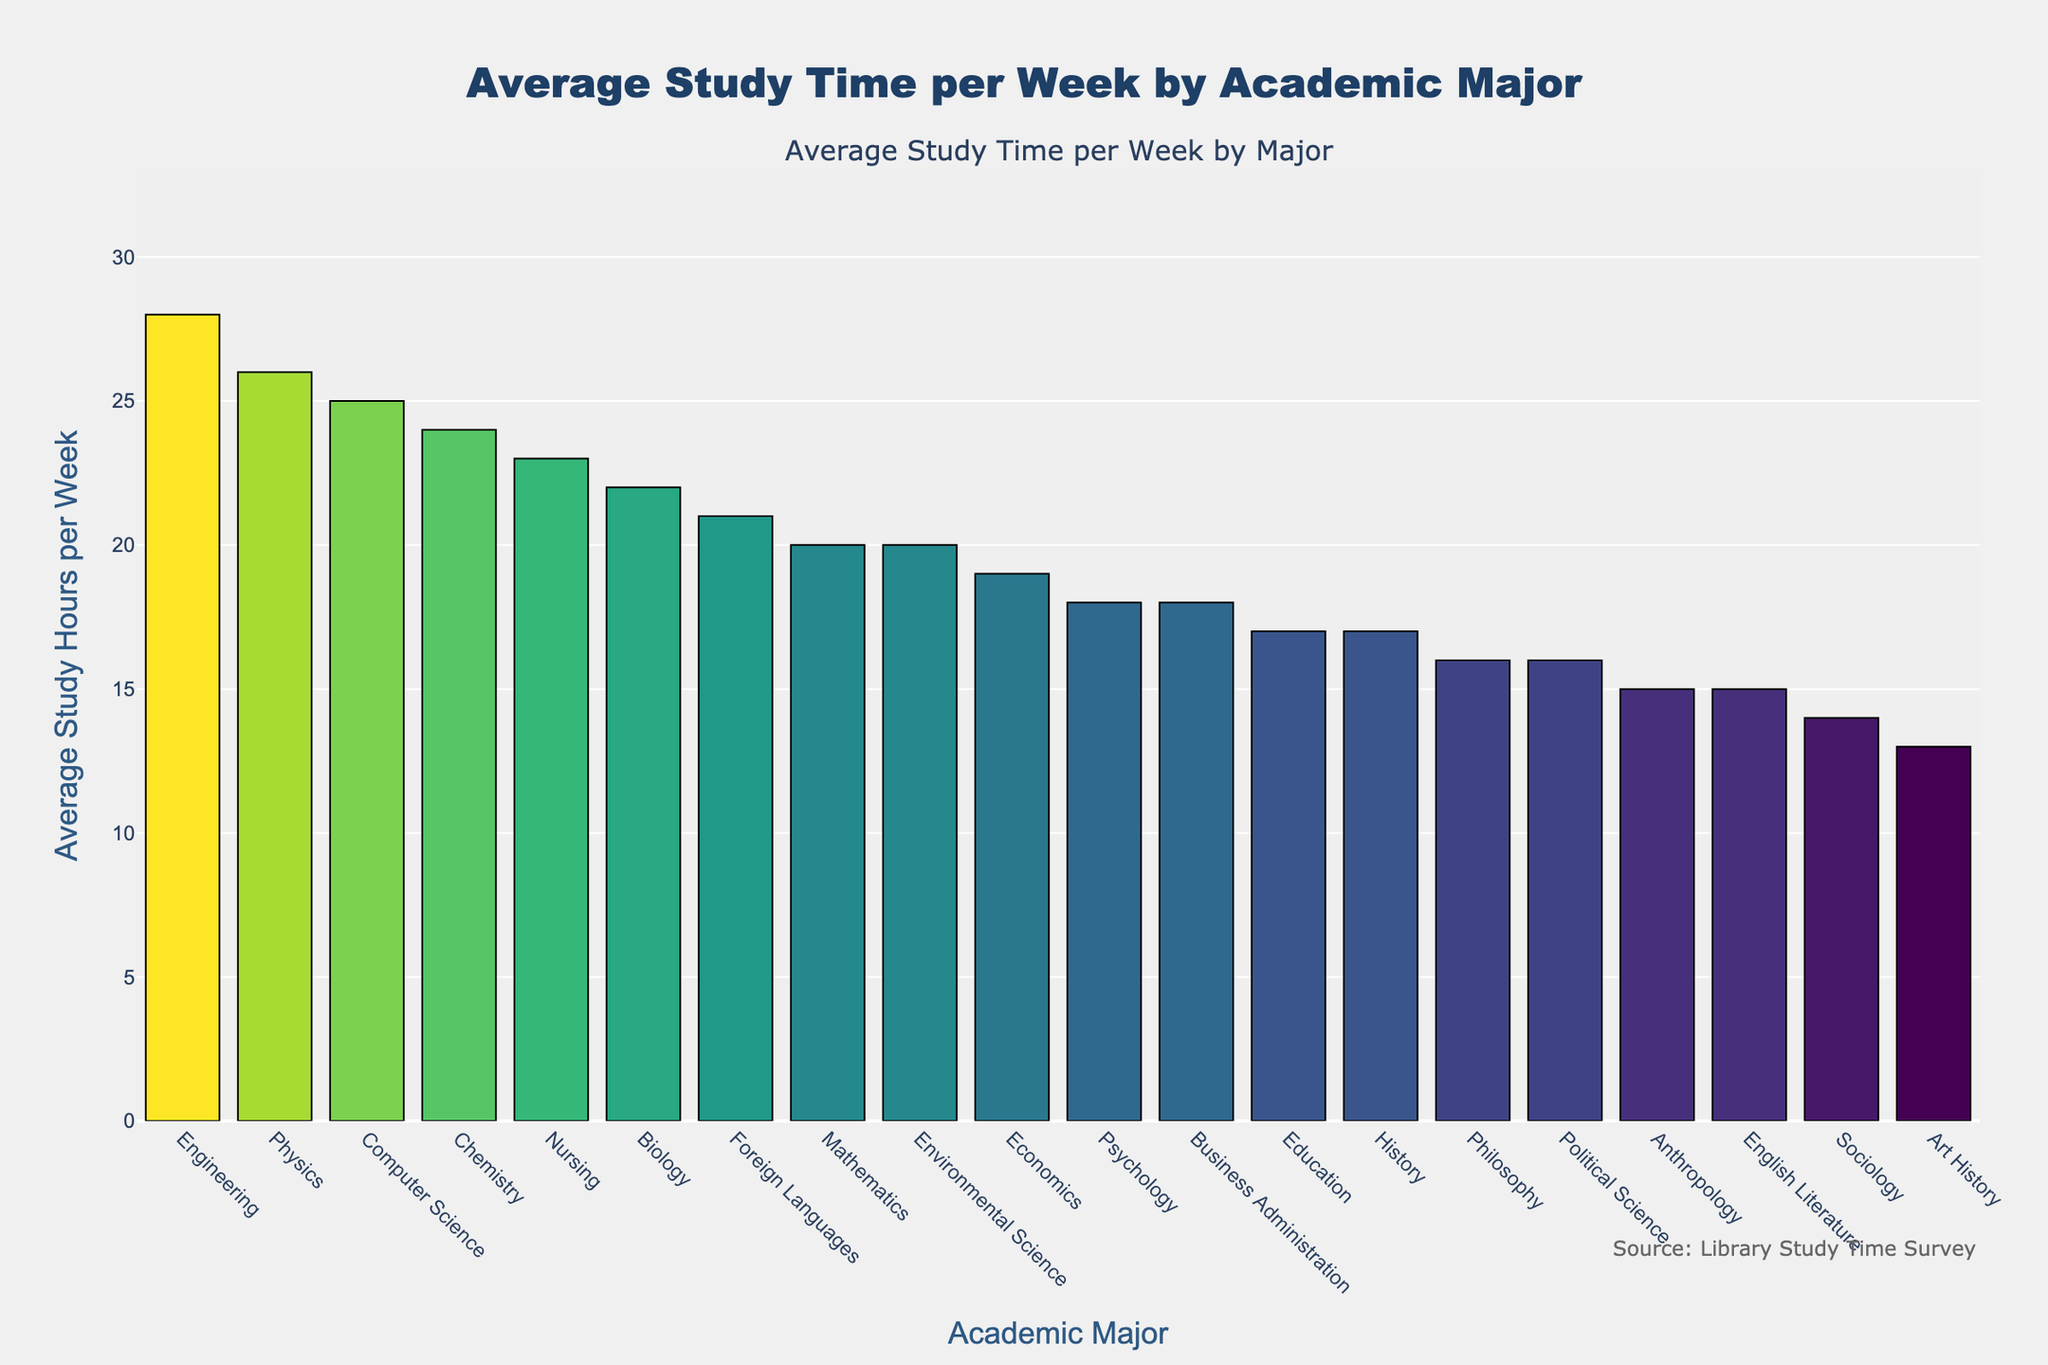What's the major with the highest average study hours per week? Identify the bar with the greatest height, which represents the major with the highest average study hours. The tallest bar corresponds to Engineering.
Answer: Engineering What's the difference in study hours between Computer Science and English Literature? Find the average study hours for Computer Science (25) and English Literature (15). Subtract the smaller value from the larger: 25 - 15.
Answer: 10 Which major has fewer average study hours per week, History or Psychology? Compare the heights of the bars for History (17 hours) and Psychology (18 hours). History has fewer average study hours.
Answer: History Rank the top three majors in terms of average weekly study hours. Identify the three tallest bars. The majors are Engineering (28 hours), Physics (26 hours), and Computer Science (25 hours).
Answer: Engineering, Physics, Computer Science What is the total study hours per week for Biology, Chemistry, and Nursing combined? Add the average study hours for Biology (22), Chemistry (24), and Nursing (23): 22 + 24 + 23.
Answer: 69 Which major has the shortest average study hours per week, and how many hours is it? Identify the bar with the shortest height, which represents Art History, with 13 hours.
Answer: Art History, 13 How does the average study time for Mathematics compare to Economics? Identify the average study hours for Mathematics (20) and Economics (19). Mathematics has 1 hour more than Economics.
Answer: Mathematics has more What is the average study hours per week of all majors combined? Sum the study hours for all majors, then divide by the number of majors (20). Calculation: (15 + 25 + 22 + 18 + 20 + 17 + 24 + 19 + 23 + 16 + 28 + 14 + 26 + 18 + 13 + 16 + 21 + 15 + 20 + 17) / 20.
Answer: 19.35 Which major in the social sciences (Psychology, Sociology, Anthropology, Education) has the highest average study hours per week? Compare the average study hours for Psychology (18), Sociology (14), Anthropology (15), and Education (17). Psychology has the highest at 18 hours.
Answer: Psychology 